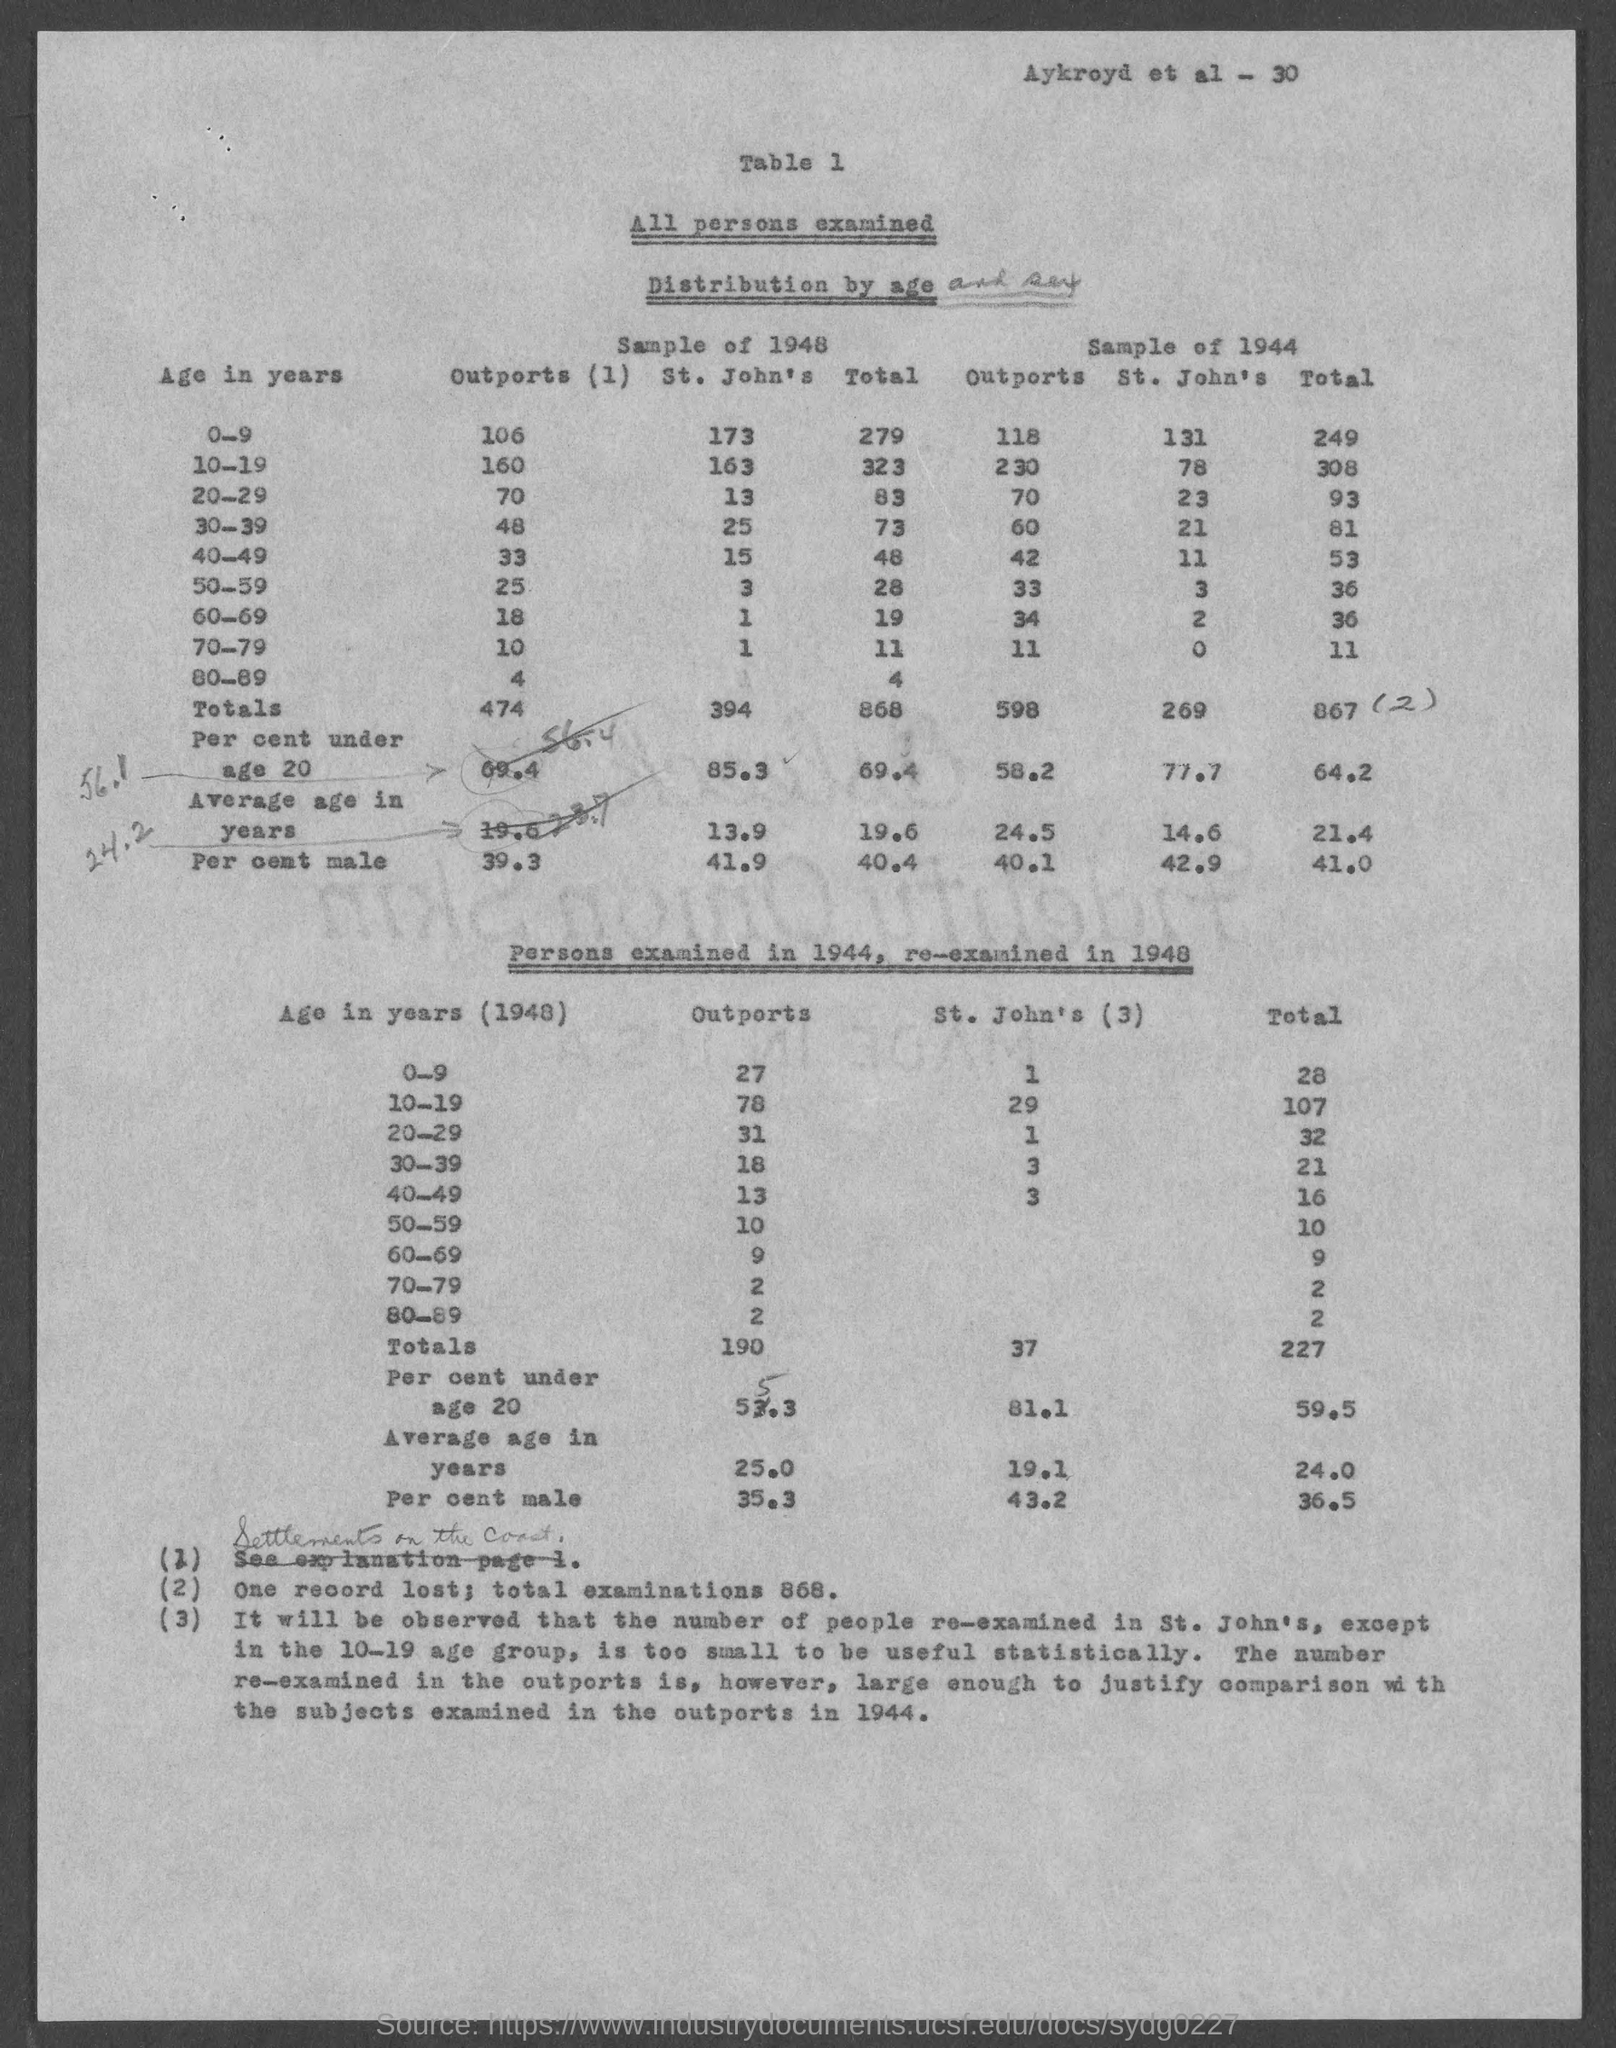Highlight a few significant elements in this photo. There were a total of 868 examinations. 